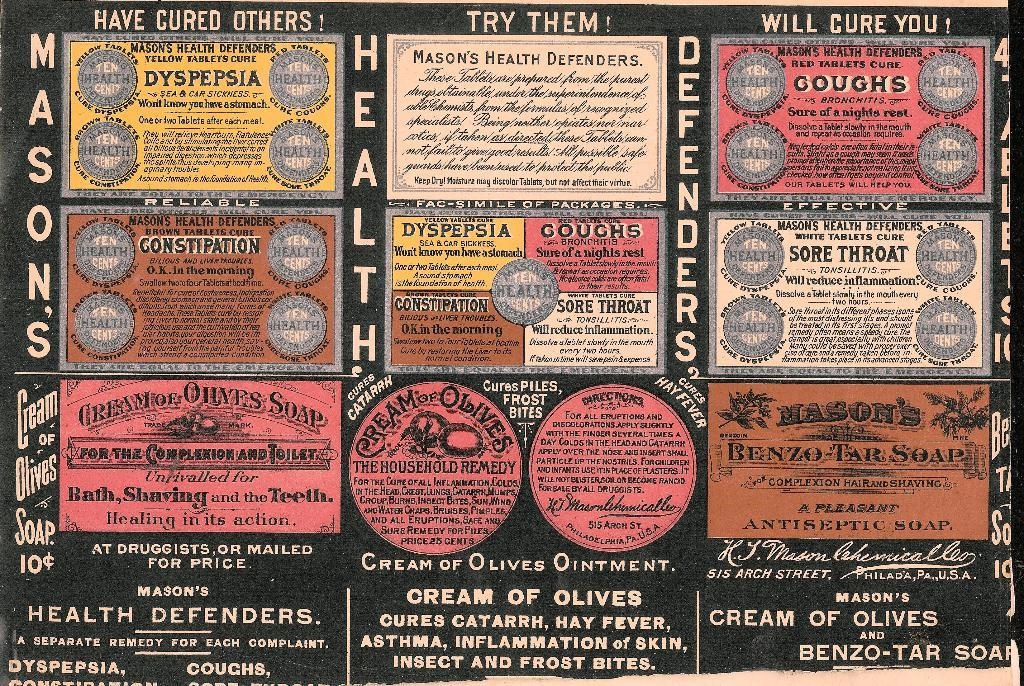<image>
Write a terse but informative summary of the picture. a page that says 'mason's health defenders' on it 